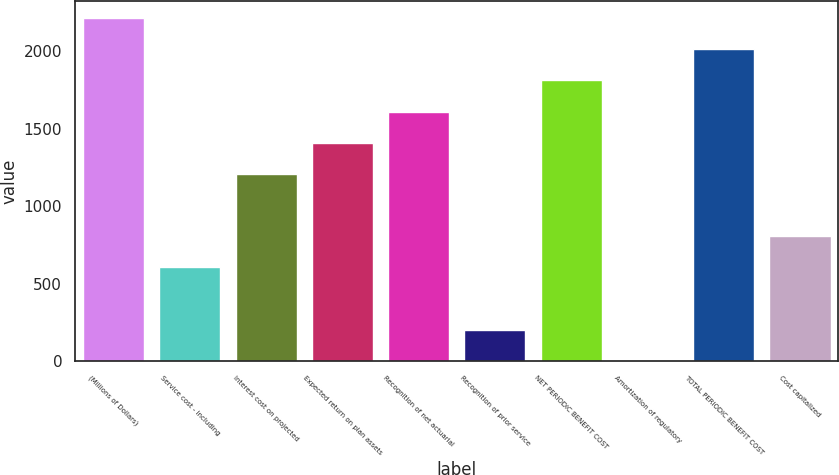<chart> <loc_0><loc_0><loc_500><loc_500><bar_chart><fcel>(Millions of Dollars)<fcel>Service cost - including<fcel>Interest cost on projected<fcel>Expected return on plan assets<fcel>Recognition of net actuarial<fcel>Recognition of prior service<fcel>NET PERIODIC BENEFIT COST<fcel>Amortization of regulatory<fcel>TOTAL PERIODIC BENEFIT COST<fcel>Cost capitalized<nl><fcel>2214.1<fcel>605.3<fcel>1208.6<fcel>1409.7<fcel>1610.8<fcel>203.1<fcel>1811.9<fcel>2<fcel>2013<fcel>806.4<nl></chart> 